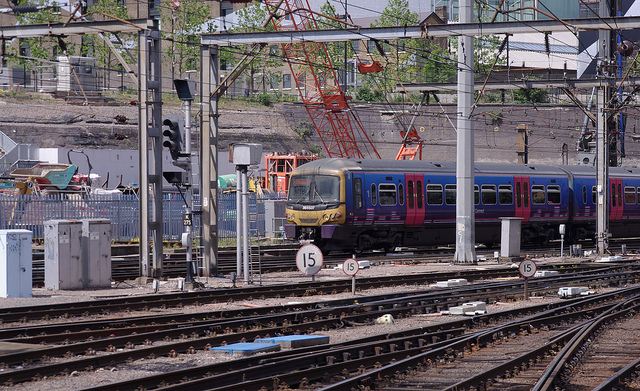Identify the text displayed in this image. 15 15 